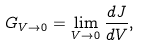Convert formula to latex. <formula><loc_0><loc_0><loc_500><loc_500>G _ { V \rightarrow 0 } = \lim _ { V \rightarrow 0 } \frac { d J } { d V } ,</formula> 